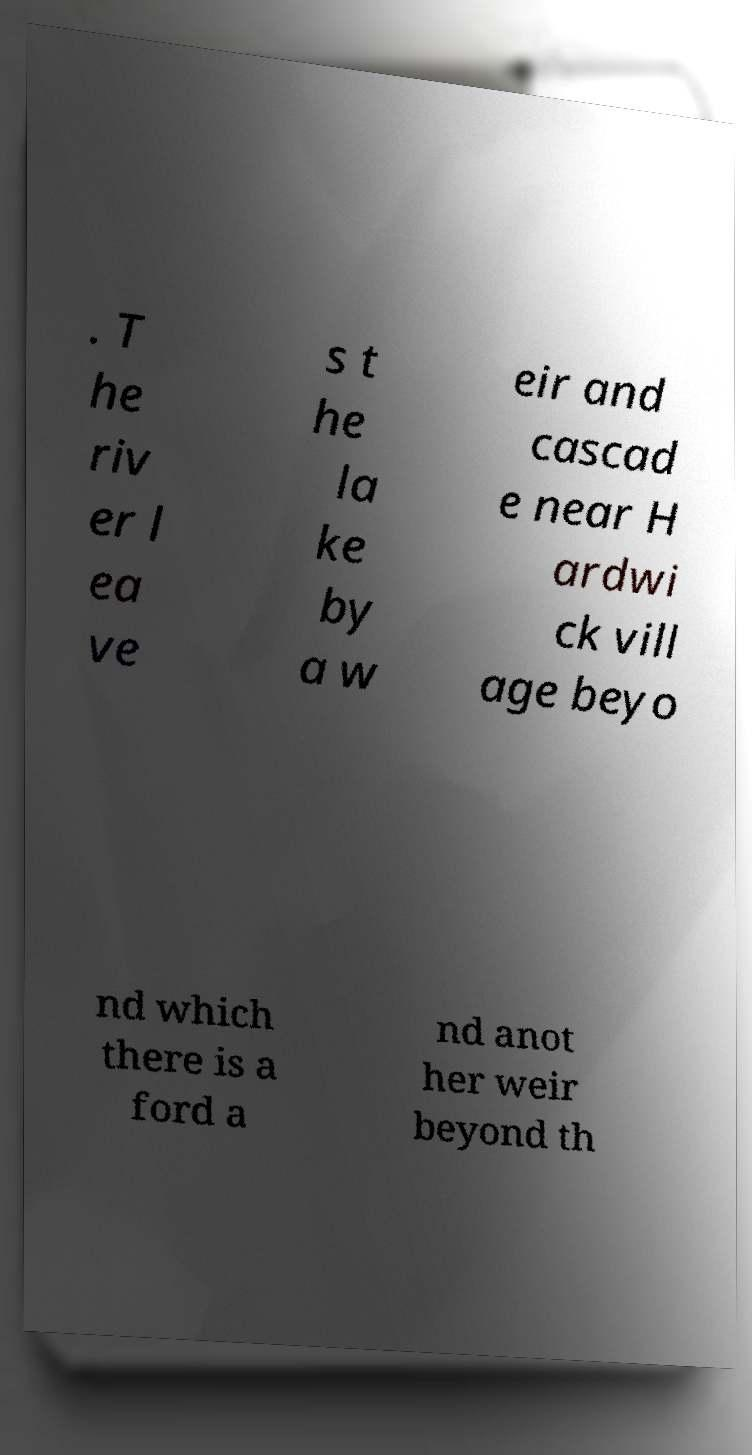For documentation purposes, I need the text within this image transcribed. Could you provide that? . T he riv er l ea ve s t he la ke by a w eir and cascad e near H ardwi ck vill age beyo nd which there is a ford a nd anot her weir beyond th 